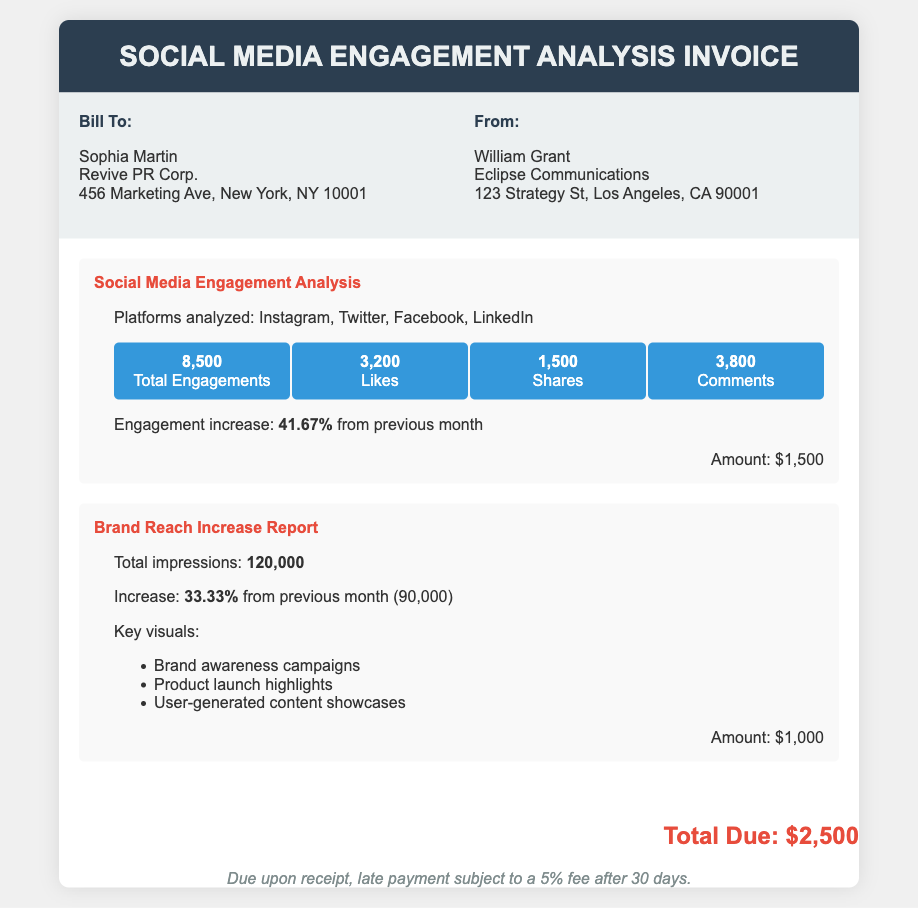What is the total number of engagements? The total engagements are listed in the document as 8,500.
Answer: 8,500 What is the increase in engagement from the previous month? The document states the engagement increase is 41.67% from the previous month.
Answer: 41.67% Who is the bill sent to? The document lists the recipient as Sophia Martin at Revive PR Corp.
Answer: Sophia Martin What was the total number of impressions reported? The total number of impressions reported in the document is 120,000.
Answer: 120,000 What is the total amount due for the invoice? The total due amount is explicitly mentioned in the document as $2,500.
Answer: $2,500 What platforms were analyzed for social media engagement? The platforms analyzed are Instagram, Twitter, Facebook, and LinkedIn.
Answer: Instagram, Twitter, Facebook, LinkedIn What is the increase in brand reach from the previous month? The increase in brand reach is noted as 33.33% from the previous month.
Answer: 33.33% Who issued the invoice? The document indicates that William Grant from Eclipse Communications issued the invoice.
Answer: William Grant What is the cost for the Brand Reach Increase Report? The document specifies that the amount for the Brand Reach Increase Report is $1,000.
Answer: $1,000 